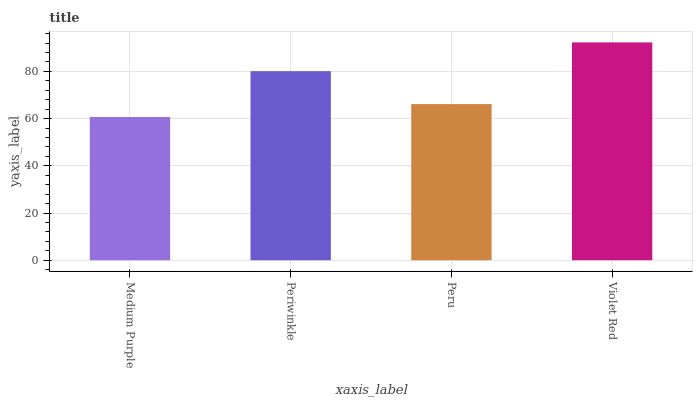Is Medium Purple the minimum?
Answer yes or no. Yes. Is Violet Red the maximum?
Answer yes or no. Yes. Is Periwinkle the minimum?
Answer yes or no. No. Is Periwinkle the maximum?
Answer yes or no. No. Is Periwinkle greater than Medium Purple?
Answer yes or no. Yes. Is Medium Purple less than Periwinkle?
Answer yes or no. Yes. Is Medium Purple greater than Periwinkle?
Answer yes or no. No. Is Periwinkle less than Medium Purple?
Answer yes or no. No. Is Periwinkle the high median?
Answer yes or no. Yes. Is Peru the low median?
Answer yes or no. Yes. Is Peru the high median?
Answer yes or no. No. Is Medium Purple the low median?
Answer yes or no. No. 